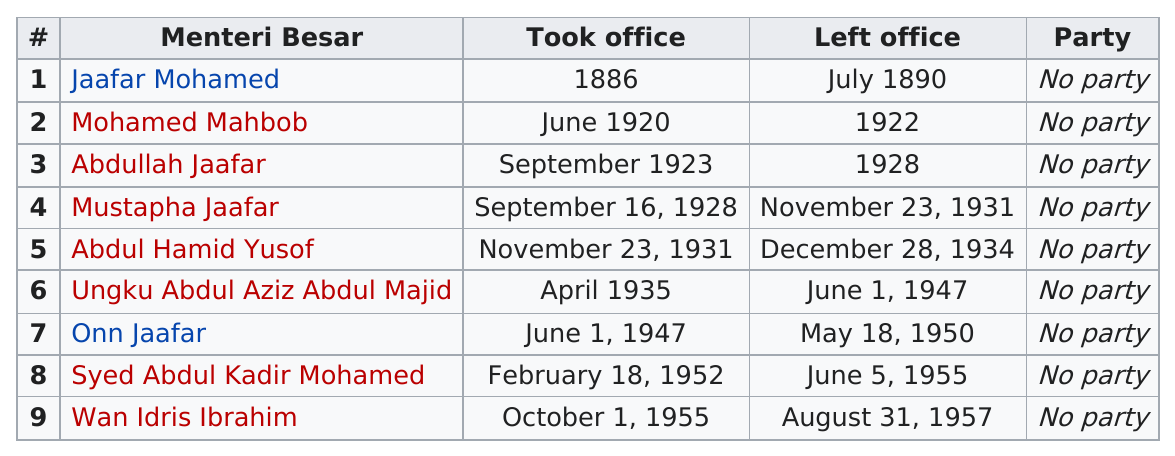Identify some key points in this picture. Ungku Abdul Aziz Abdul Majid is the person who spends the most amount of time in the office. Jaafar Mohamed served in office for a total of 4 years. Jaafar Mohamed was the first person to hold office. Ungku Abdul Aziz Abdul Majid served for a total of 12 years. There have been three menteri besars who have served for four or more years. 